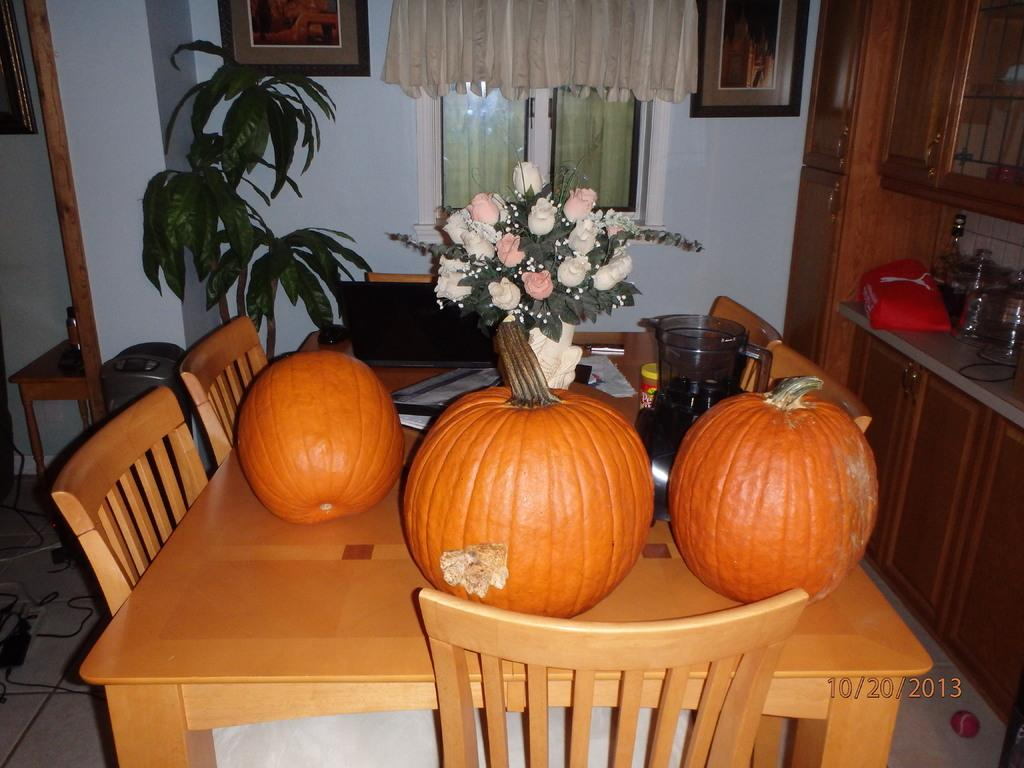What type of vegetable is present on the table in the image? There are pumpkins on the table in the image. What other living organism can be seen in the image? There is a plant in the image. What type of furniture is visible in the image? There are chairs in the image. What decorative item is present on the wall in the image? There is a photo frame on the wall. What type of window treatment is present in the image? There are curtains on the window. What type of disease is affecting the plant in the image? There is no indication of any disease affecting the plant in the image. 